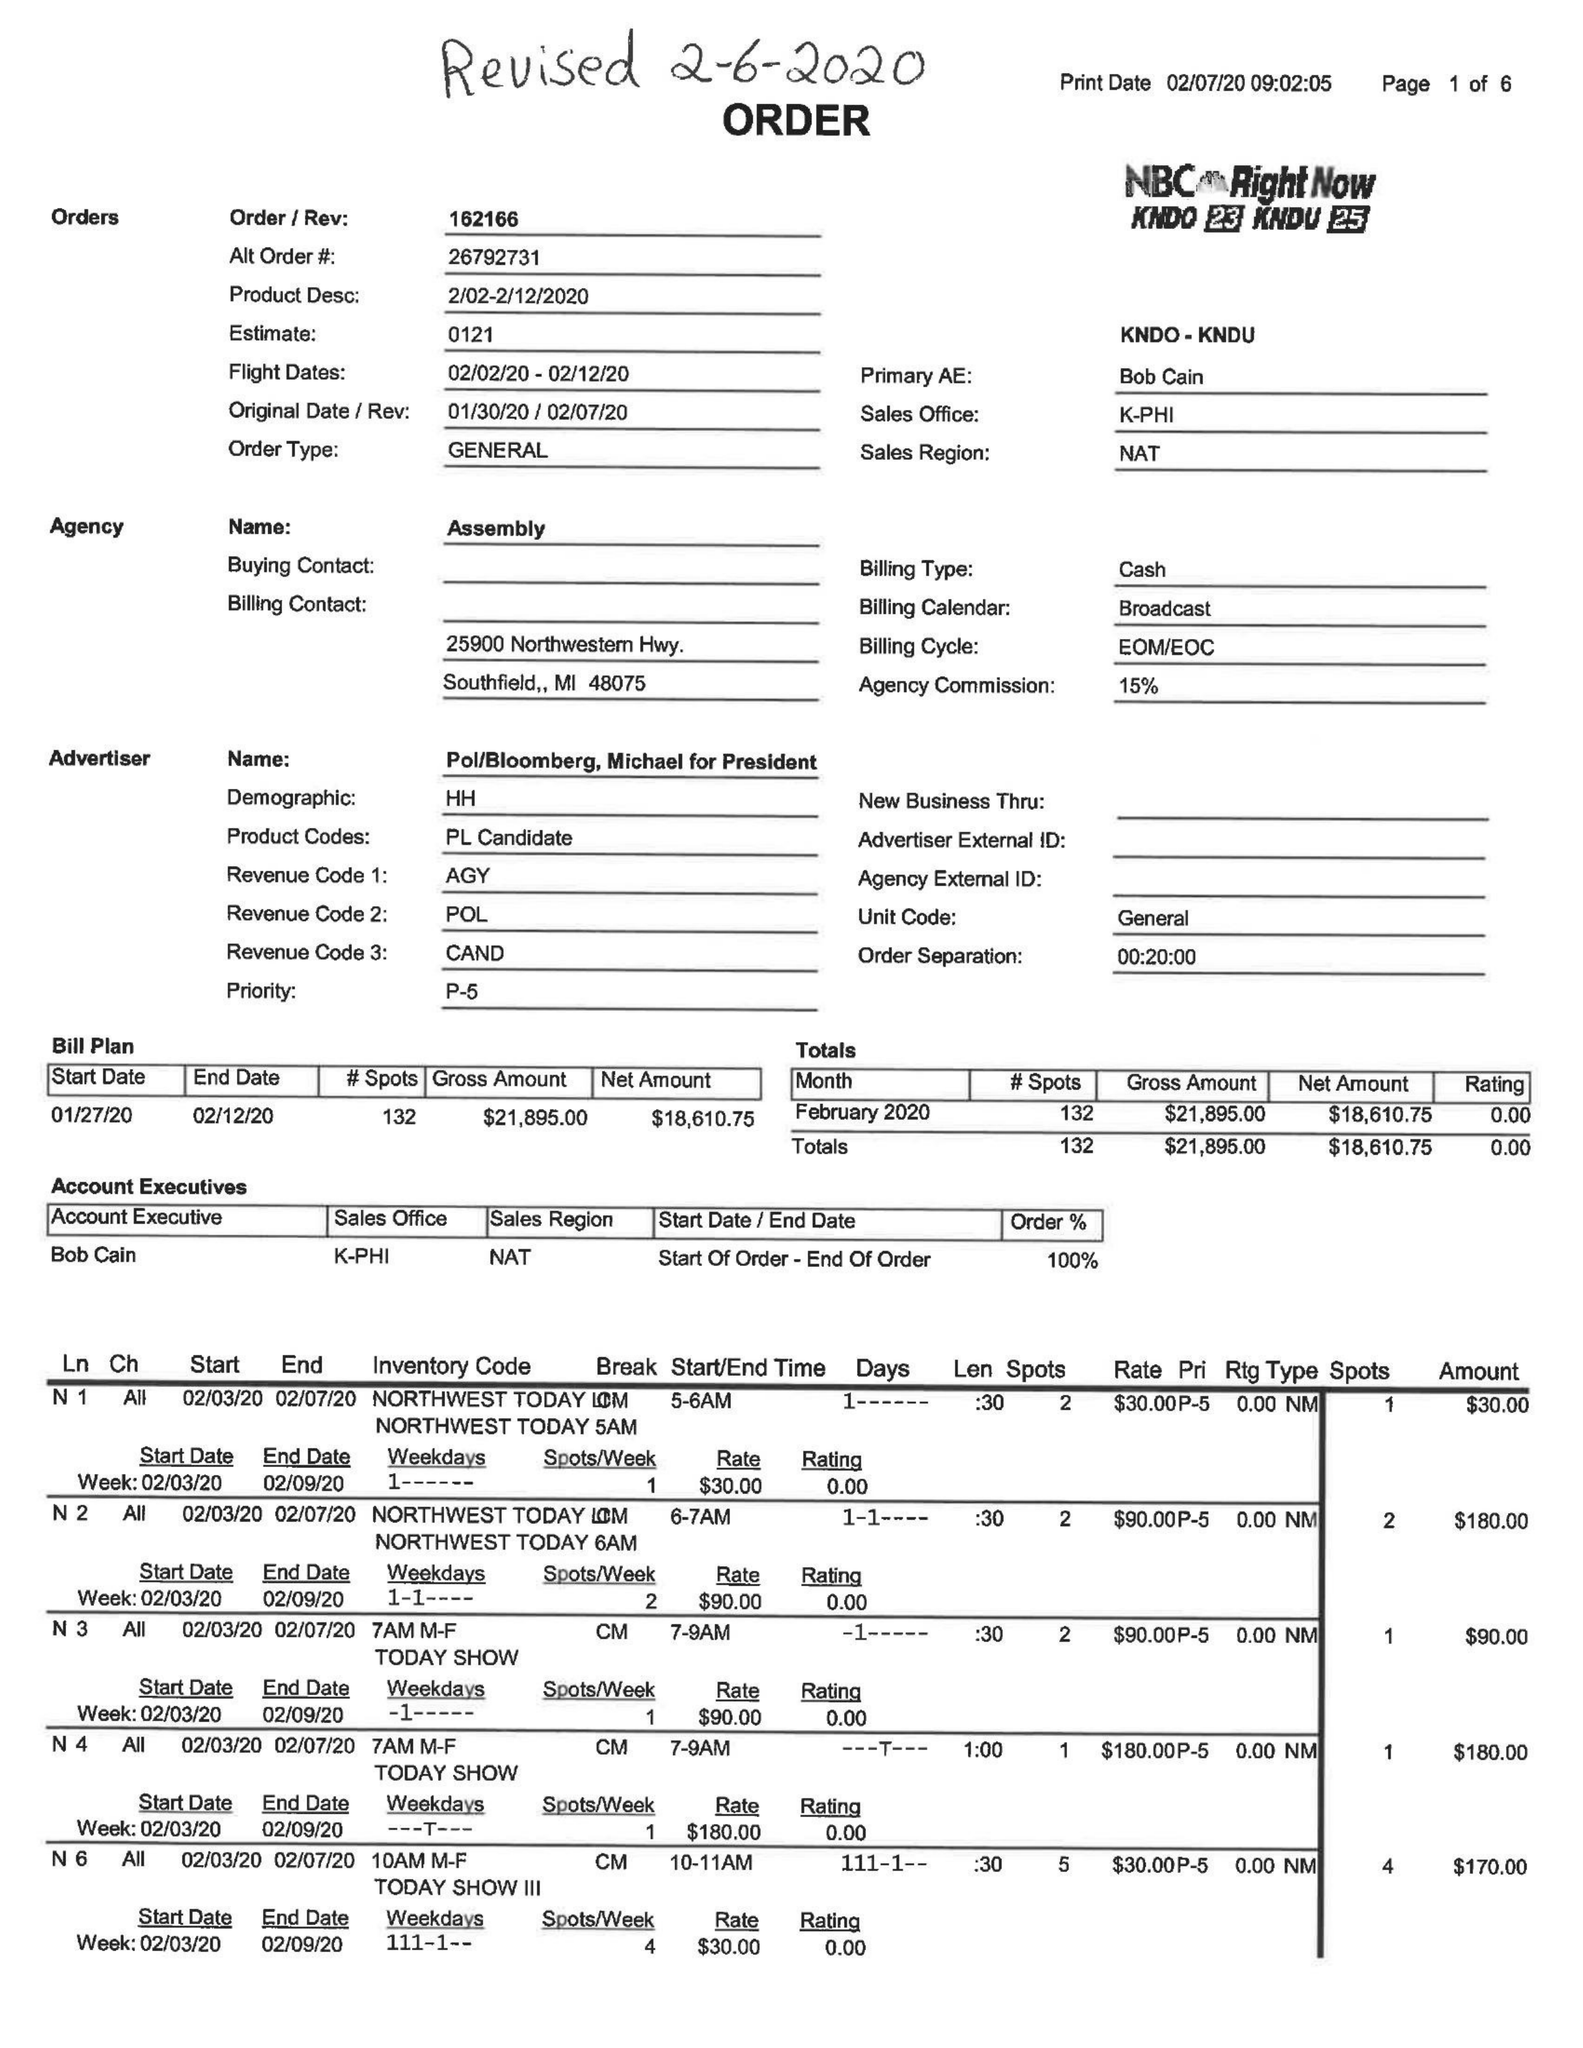What is the value for the gross_amount?
Answer the question using a single word or phrase. 21895.00 